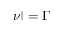<formula> <loc_0><loc_0><loc_500><loc_500>| \nu | = \Gamma</formula> 